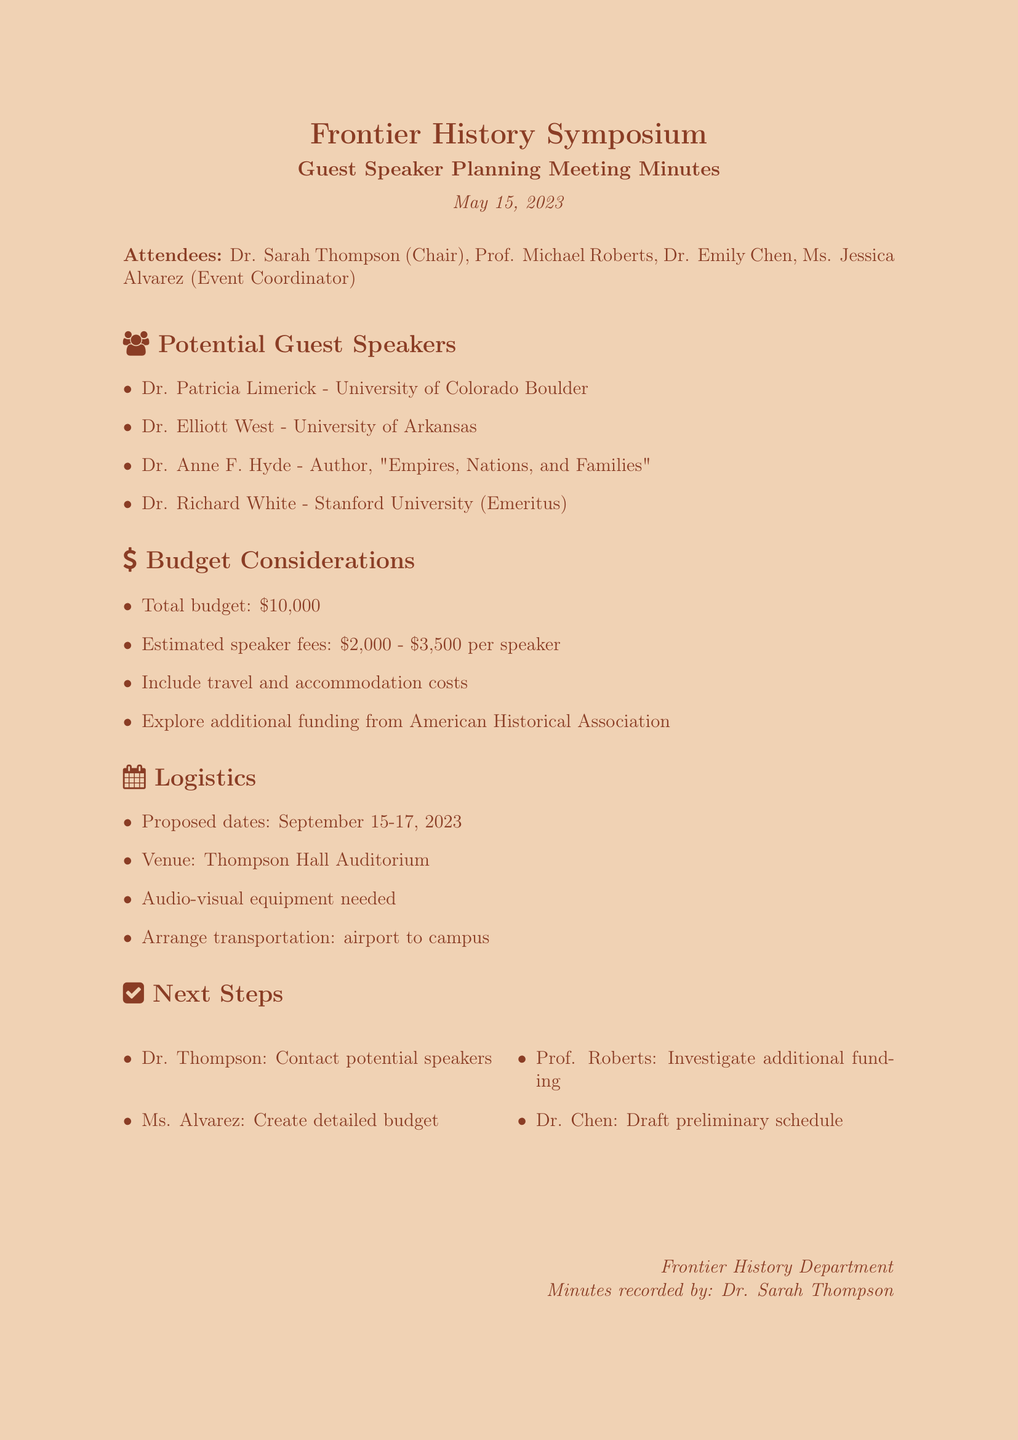What is the date of the meeting? The document provides the date at the beginning, which is listed under the title section.
Answer: May 15, 2023 Who is the chair of the meeting? The attendees section identifies Dr. Sarah Thompson as the Chair of the meeting.
Answer: Dr. Sarah Thompson What is the total budget allocated for guest speakers? The budget considerations section specifically mentions the total budget allocated for guest speakers.
Answer: $10,000 What is the proposed venue for the symposium? The logistics section notes that the venue for the symposium is Thompson Hall Auditorium.
Answer: Thompson Hall Auditorium Which historian is from Stanford University? The section on potential guest speakers lists Dr. Richard White as a professor emeritus from Stanford University.
Answer: Dr. Richard White What are the proposed dates for the symposium? The logistics section states the proposed dates for the event.
Answer: September 15-17, 2023 Who is responsible for creating a detailed budget? The next steps section assigns the task of creating a detailed budget to Ms. Alvarez.
Answer: Ms. Alvarez What are the speaker fees estimated to be? The budget considerations section mentions the estimated speaker fees for each speaker.
Answer: $2,000 - $3,500 per speaker What is the purpose of the document? The document is meant to summarize a meeting that discusses planning guest speakers for a symposium, making it a record of proceedings.
Answer: Guest Speaker Planning Meeting Minutes 